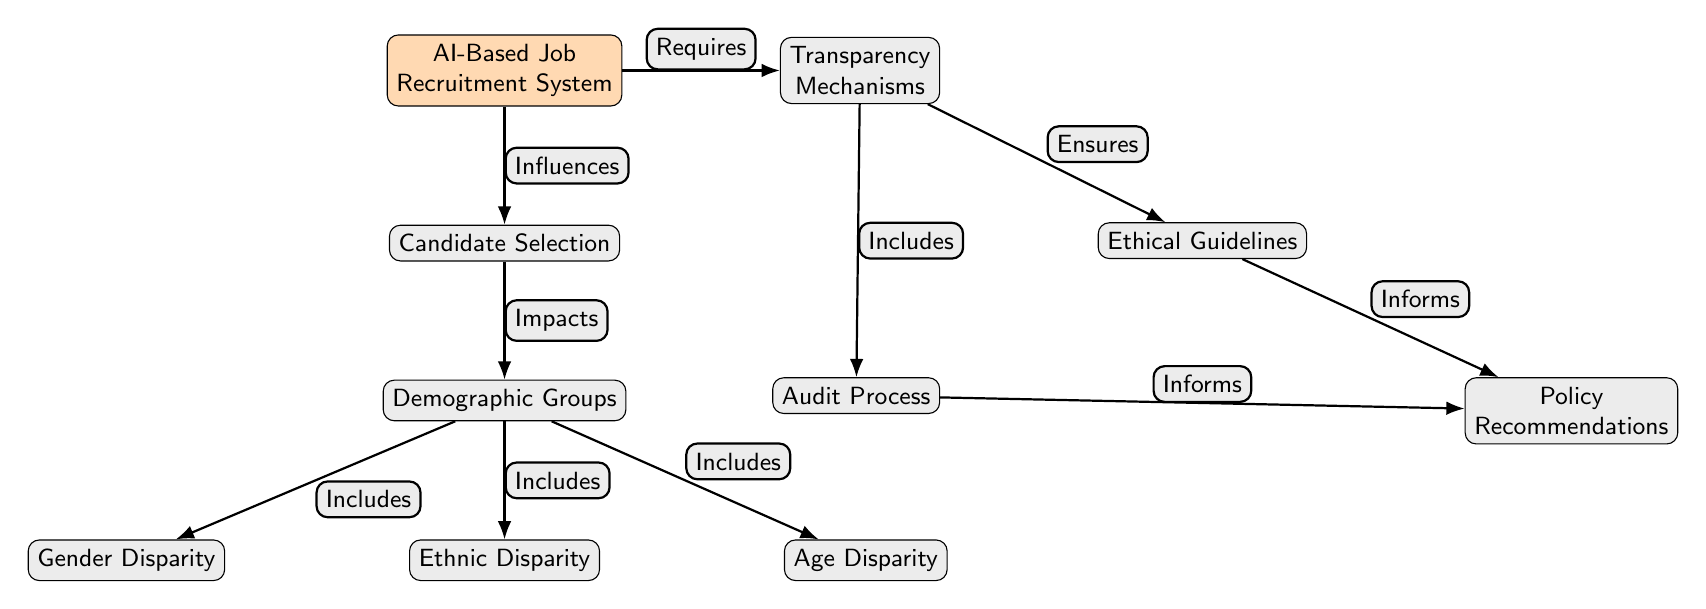What is the main system visualized in the diagram? The diagram centers around the "AI-Based Job Recruitment System," which is the primary node at the top of the diagram.
Answer: AI-Based Job Recruitment System How many demographic disparities are included in the diagram? The diagram shows three distinct demographic disparities: Gender Disparity, Ethnic Disparity, and Age Disparity, which are included as nodes under Demographic Groups.
Answer: Three What relationship exists between Candidate Selection and Demographic Groups? According to the diagram, the Candidate Selection node "Impacts" the Demographic Groups node, indicating a direct influence.
Answer: Impacts Which component ensures the ethical guidelines related to the AI system? The Transparency Mechanisms node "Ensures" the Ethical Guidelines node, indicating its role in maintaining ethical standards in the recruitment process.
Answer: Transparency Mechanisms What is the connection between the Audit Process and Policy Recommendations? The diagram shows that the Audit Process "Informs" the Policy Recommendations, indicating that outcomes from audits can shape policies.
Answer: Informs What is the purpose of Transparency Mechanisms in this system? Transparency Mechanisms are depicted as a component that "Requires" the AI-Based Job Recruitment System, suggesting their necessity for the ethical operation of the system.
Answer: Requires How do Ethical Guidelines relate to Policy Recommendations? The Ethical Guidelines node "Informs" the Policy Recommendations node, meaning the guidelines provide essential insights used to formulate those recommendations.
Answer: Informs What node is positioned directly below Candidate Selection? The Demographic Groups node is positioned directly below Candidate Selection in the diagram, indicating a hierarchical relationship.
Answer: Demographic Groups Which node influences the Candidate Selection process? The AI-Based Job Recruitment System node is shown to "Influence" the Candidate Selection process, indicating its role in shaping how candidates are selected.
Answer: Influences 